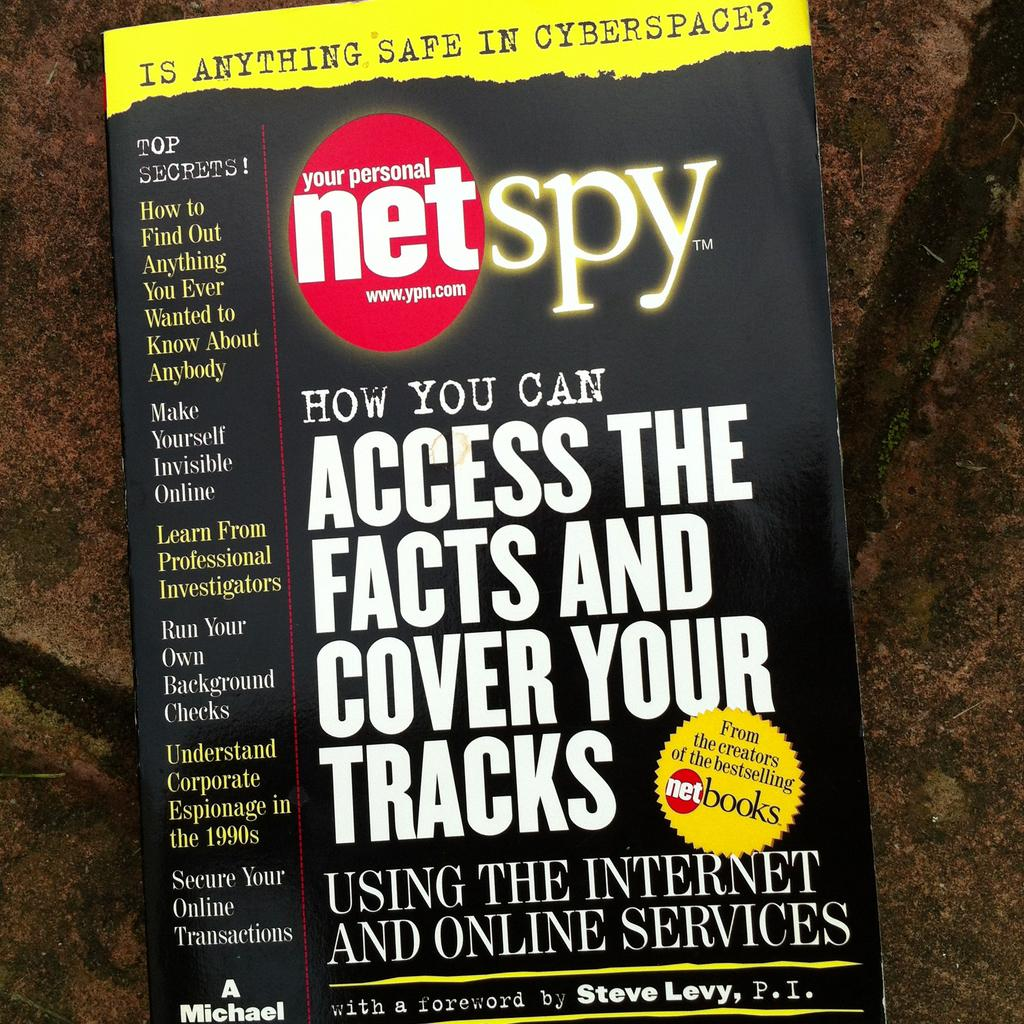What object can be seen in the image? A: There is a book in the image. Where is the book located? The book is on a surface. What can be found on the book? There is writing on the book. What type of verse can be heard being recited by the crowd in the image? There is no crowd or verse present in the image; it only features a book on a surface with writing on it. 